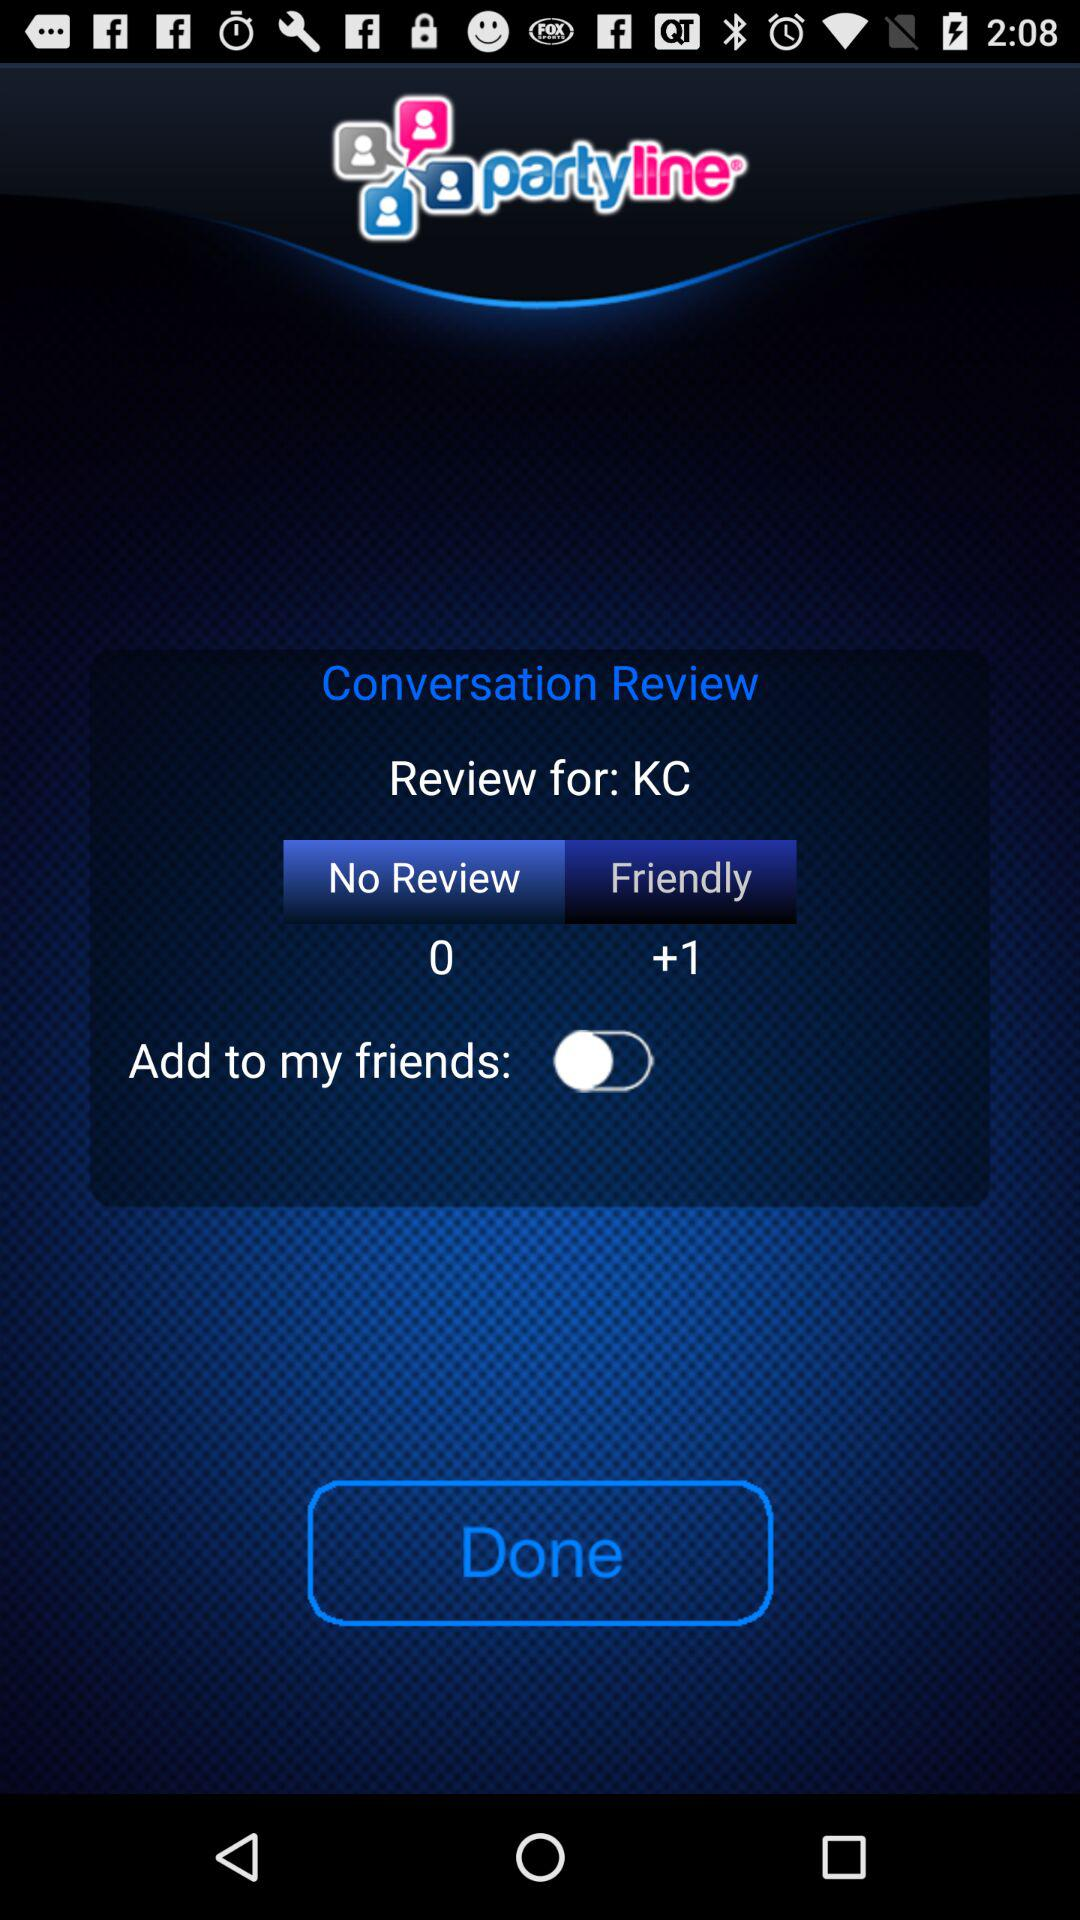What is the application name? The application name is "partyline". 